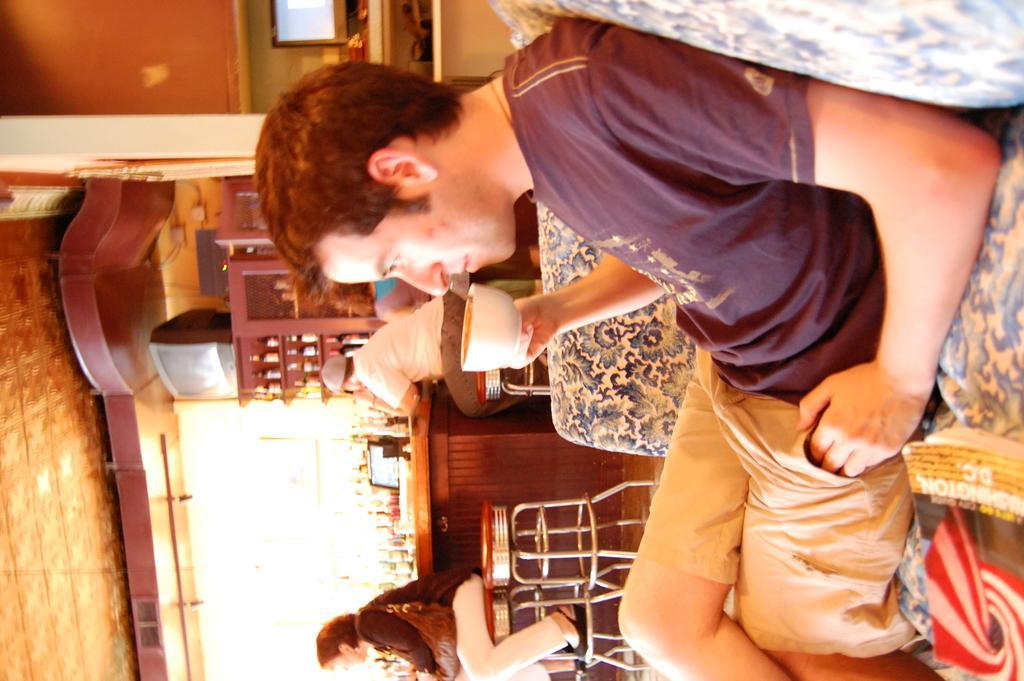Describe this image in one or two sentences. A person is sitting on the couch and holding a coffee cup. Background there are racks, chairs, tables, bottles, people and monitor. In that rock there are bottles. Above that rock there is a television.  